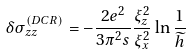Convert formula to latex. <formula><loc_0><loc_0><loc_500><loc_500>\delta \sigma _ { z z } ^ { ( D C R ) } = - \frac { 2 e ^ { 2 } } { 3 \pi ^ { 2 } s } \frac { \xi _ { z } ^ { 2 } } { \xi _ { x } ^ { 2 } } \ln \frac { 1 } { \widetilde { h } }</formula> 